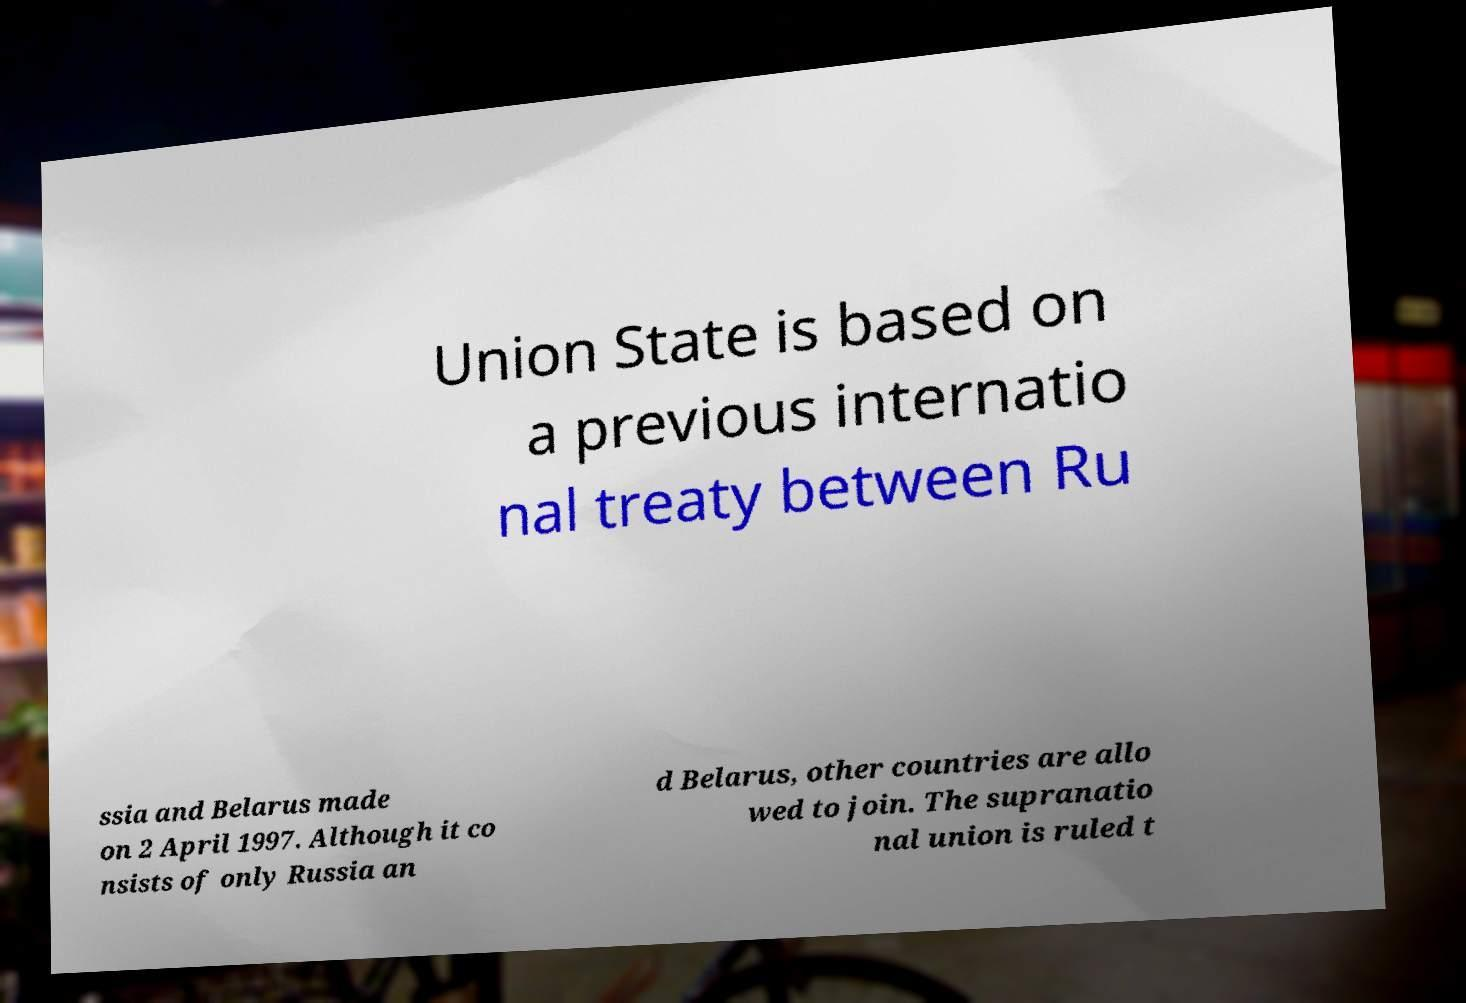Please identify and transcribe the text found in this image. Union State is based on a previous internatio nal treaty between Ru ssia and Belarus made on 2 April 1997. Although it co nsists of only Russia an d Belarus, other countries are allo wed to join. The supranatio nal union is ruled t 